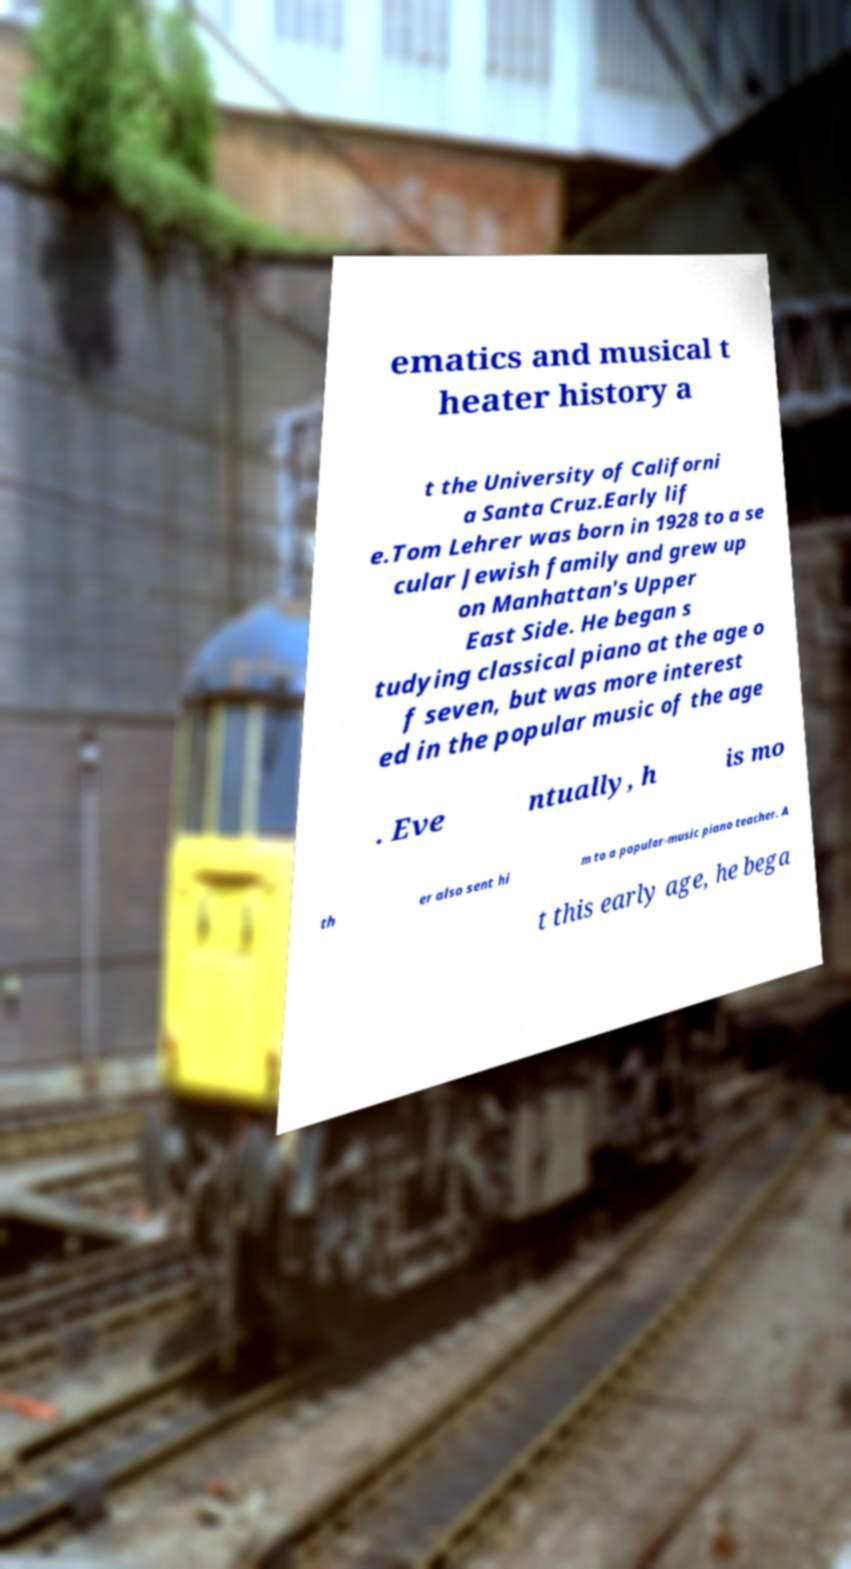For documentation purposes, I need the text within this image transcribed. Could you provide that? ematics and musical t heater history a t the University of Californi a Santa Cruz.Early lif e.Tom Lehrer was born in 1928 to a se cular Jewish family and grew up on Manhattan's Upper East Side. He began s tudying classical piano at the age o f seven, but was more interest ed in the popular music of the age . Eve ntually, h is mo th er also sent hi m to a popular-music piano teacher. A t this early age, he bega 